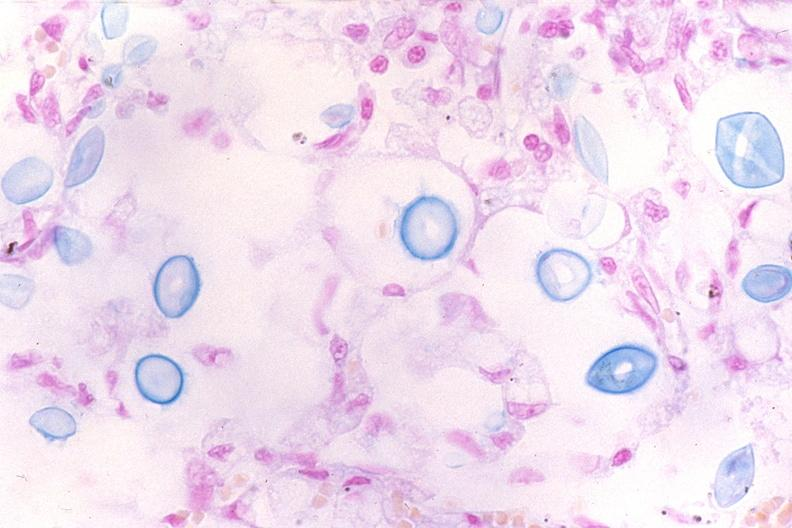does cervical leiomyoma show lung, cryptococcal pneumonia?
Answer the question using a single word or phrase. No 